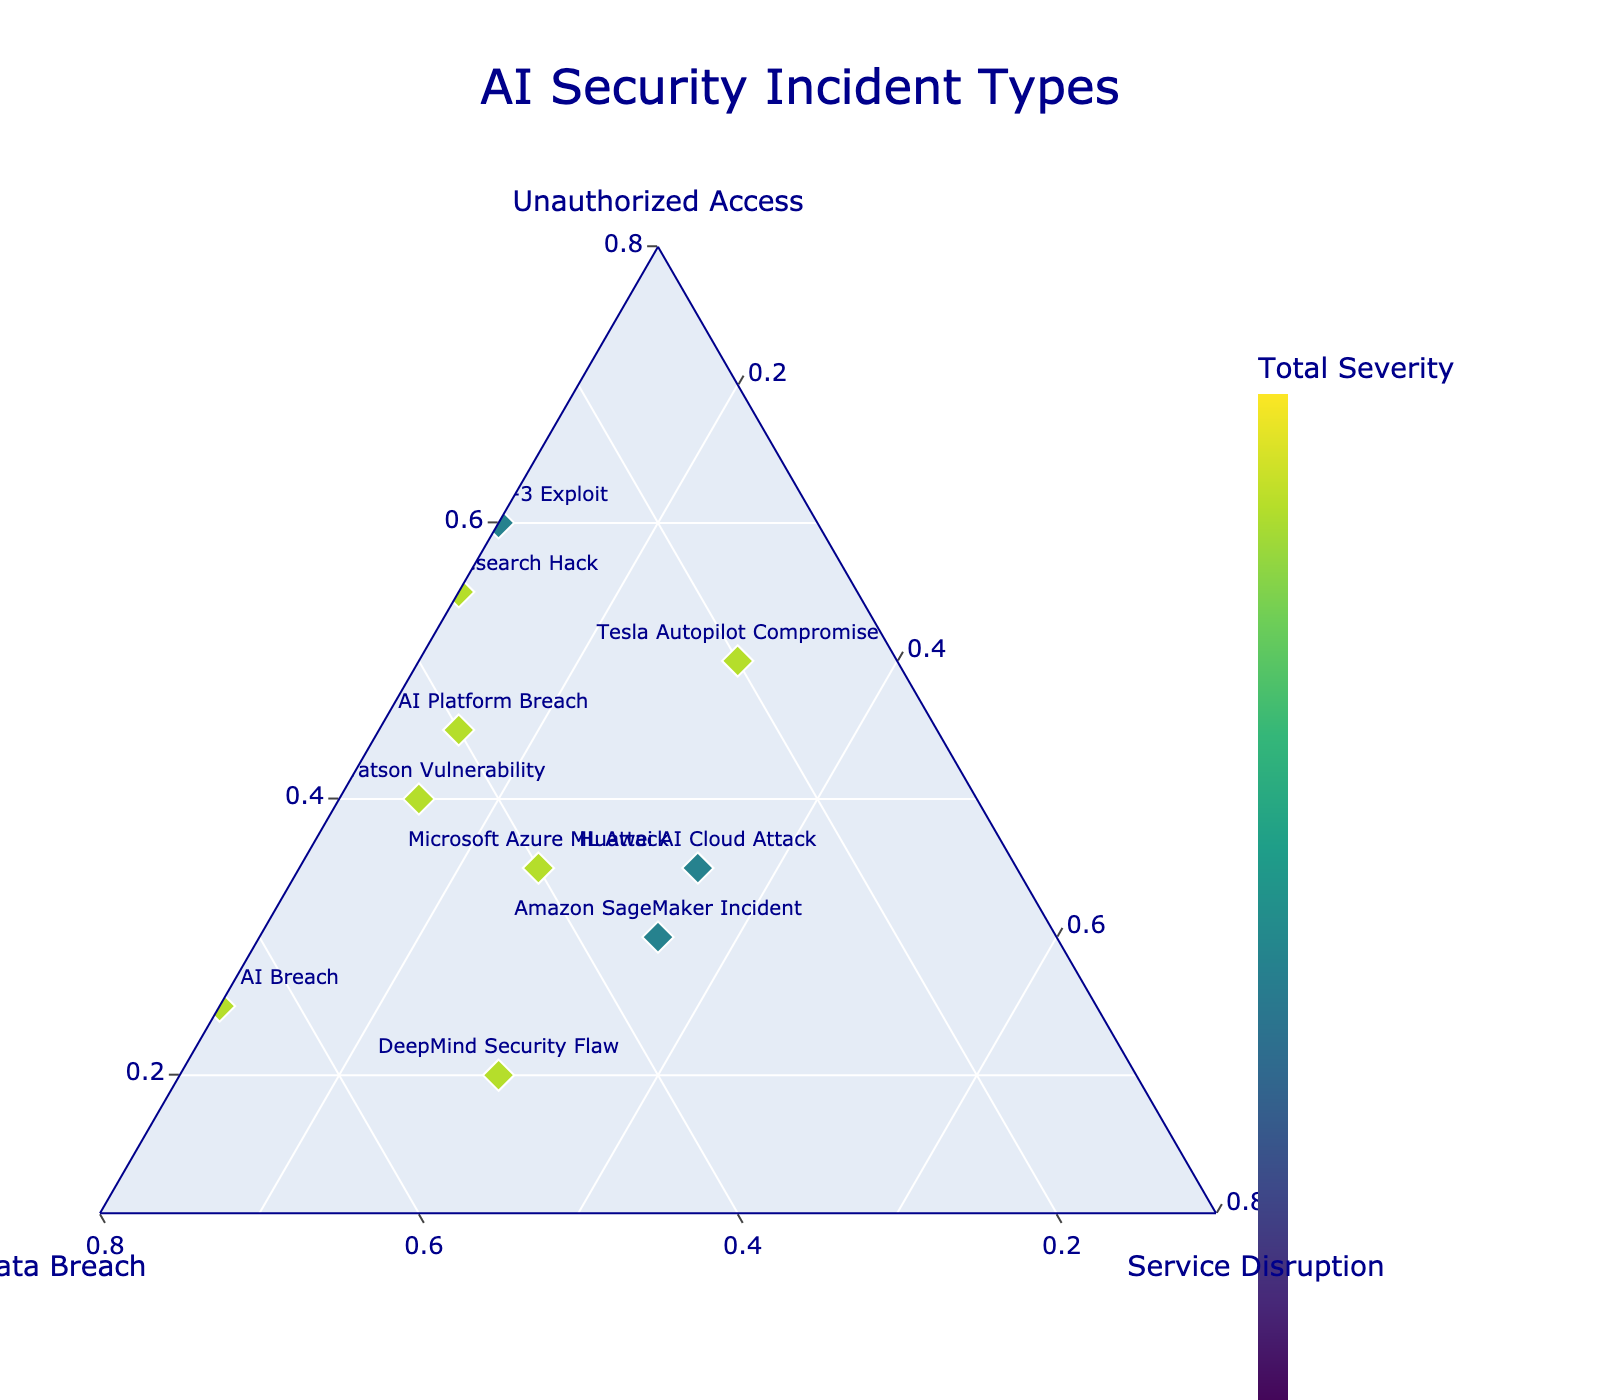Which AI incident has the highest level of Data Breach? The Google Cloud AI Breach has a Data Breach value of 0.65, which is the highest among all AI incidents. This is identified by inspecting the plot and noting the percentage value associated with each incident point.
Answer: Google Cloud AI Breach Which AI incident shows an equal distribution between Unauthorized Access and Data Breach? Amazon SageMaker Incident shows a close distribution between Unauthorized Access (0.30) and Data Breach (0.35). This can be recognized from the points positioned nearly equidistant from the Unauthorized Access and Data Breach axes.
Answer: Amazon SageMaker Incident What is the incident with the least Service Disruption value? Both OpenAI GPT-3 Exploit and Facebook AI Research Hack have the lowest Service Disruption values of 0.10. This is determined by finding points closest to the Service Disruption axis.
Answer: OpenAI GPT-3 Exploit, Facebook AI Research Hack Between IBM Watson Vulnerability and Microsoft Azure ML Attack, which one has a higher Unauthorized Access value? IBM Watson Vulnerability has a higher Unauthorized Access value (0.40) compared to Microsoft Azure ML Attack (0.35), which is identified by comparing their positions relative to the Unauthorized Access axis.
Answer: IBM Watson Vulnerability What is the range of Service Disruption values in the dataset? The Service Disruption values range from a minimum of 0.10 (OpenAI GPT-3 Exploit, Facebook AI Research Hack) to a maximum of 0.35 (Amazon SageMaker Incident, Huawei AI Cloud Attack), identified by observing the spread along the Service Disruption axis.
Answer: 0.10 to 0.35 Which incidents have the exact same Unauthorized Access value? IBM Watson Vulnerability and Nvidia AI Platform Breach both have an Unauthorized Access value of 0.45. This is identified by inspecting the plot for points that are aligned vertically on the Unauthorized Access axis.
Answer: IBM Watson Vulnerability, Nvidia AI Platform Breach What is the total severity for the Tesla Autopilot Compromise incident? The total severity is the sum of Unauthorized Access (0.50), Data Breach (0.20), and Service Disruption (0.30), resulting in 1.0. This can be calculated as follows: 0.50 + 0.20 + 0.30 = 1.0.
Answer: 1.0 Which incident has a balanced distribution across all three incident types? Amazon SageMaker Incident has a balanced distribution with values relatively close to each other: Unauthorized Access (0.30), Data Breach (0.35), and Service Disruption (0.35). This is verified by observing points that are roughly centered within the triangle.
Answer: Amazon SageMaker Incident 